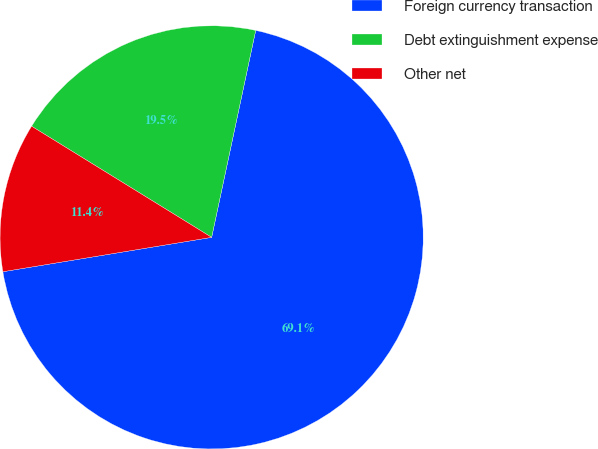<chart> <loc_0><loc_0><loc_500><loc_500><pie_chart><fcel>Foreign currency transaction<fcel>Debt extinguishment expense<fcel>Other net<nl><fcel>69.07%<fcel>19.54%<fcel>11.4%<nl></chart> 